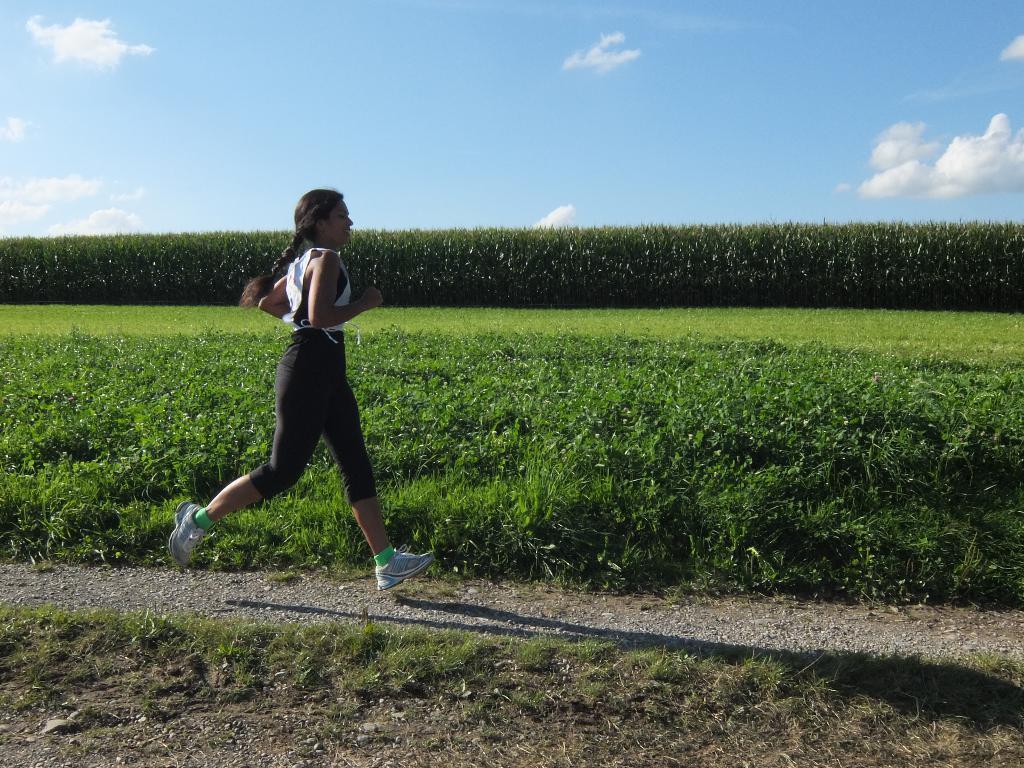Can you describe this image briefly? In the center of the image we can see girl running on the ground. In the background we can see trees, plants, sky and clouds. 